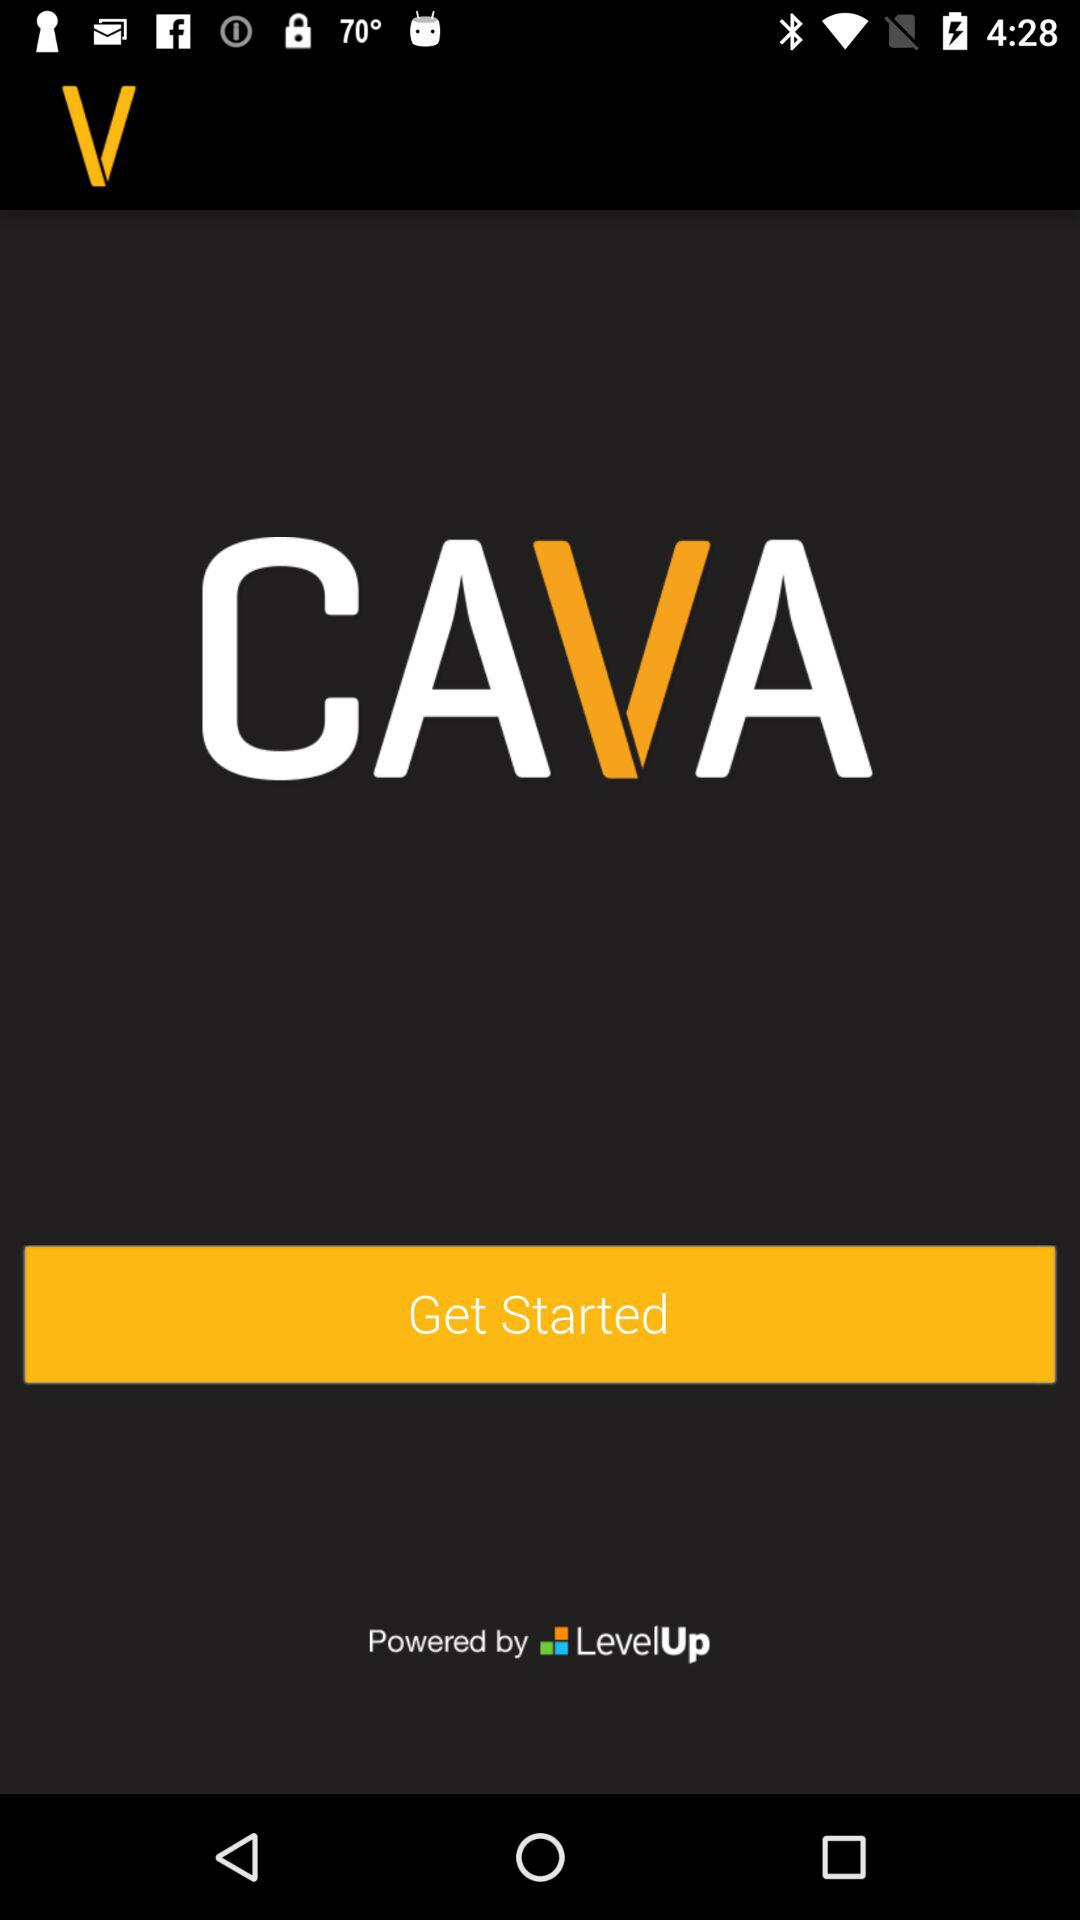What is the name of the application? The name of the application is "CAVA". 